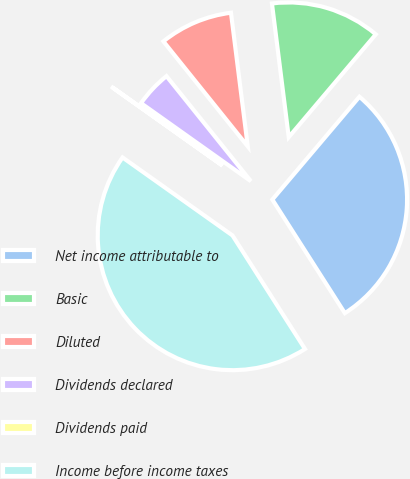Convert chart. <chart><loc_0><loc_0><loc_500><loc_500><pie_chart><fcel>Net income attributable to<fcel>Basic<fcel>Diluted<fcel>Dividends declared<fcel>Dividends paid<fcel>Income before income taxes<nl><fcel>29.77%<fcel>13.17%<fcel>8.78%<fcel>4.4%<fcel>0.01%<fcel>43.86%<nl></chart> 